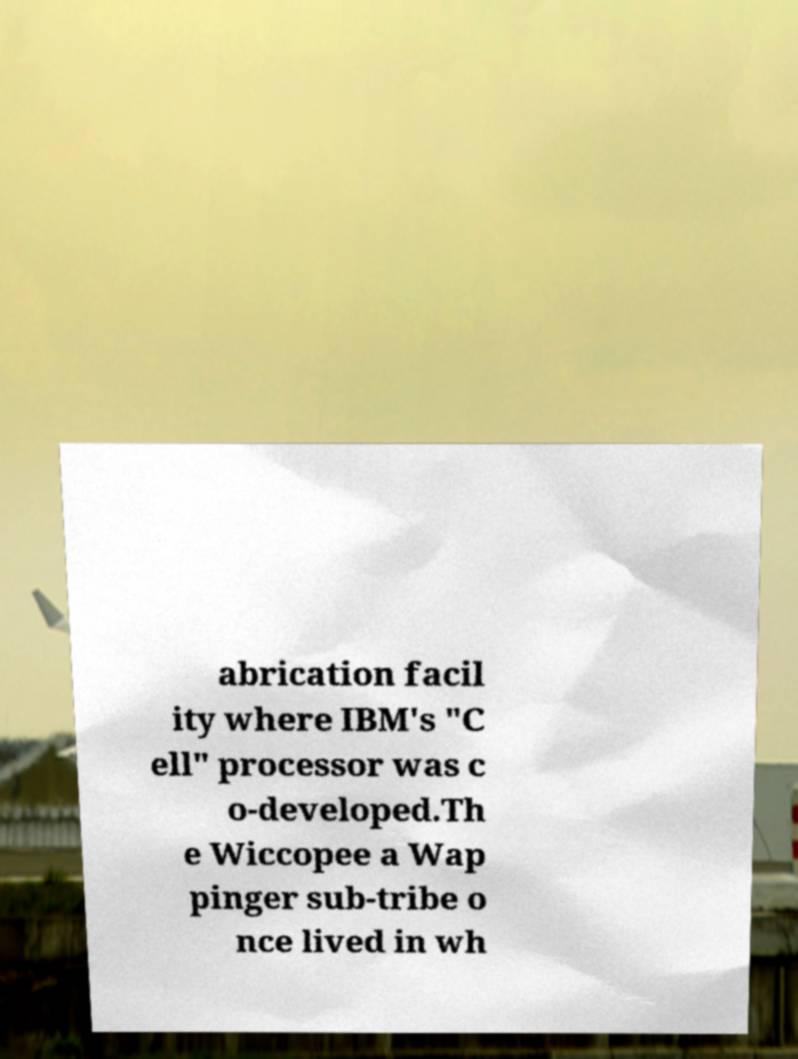Can you read and provide the text displayed in the image?This photo seems to have some interesting text. Can you extract and type it out for me? abrication facil ity where IBM's "C ell" processor was c o-developed.Th e Wiccopee a Wap pinger sub-tribe o nce lived in wh 